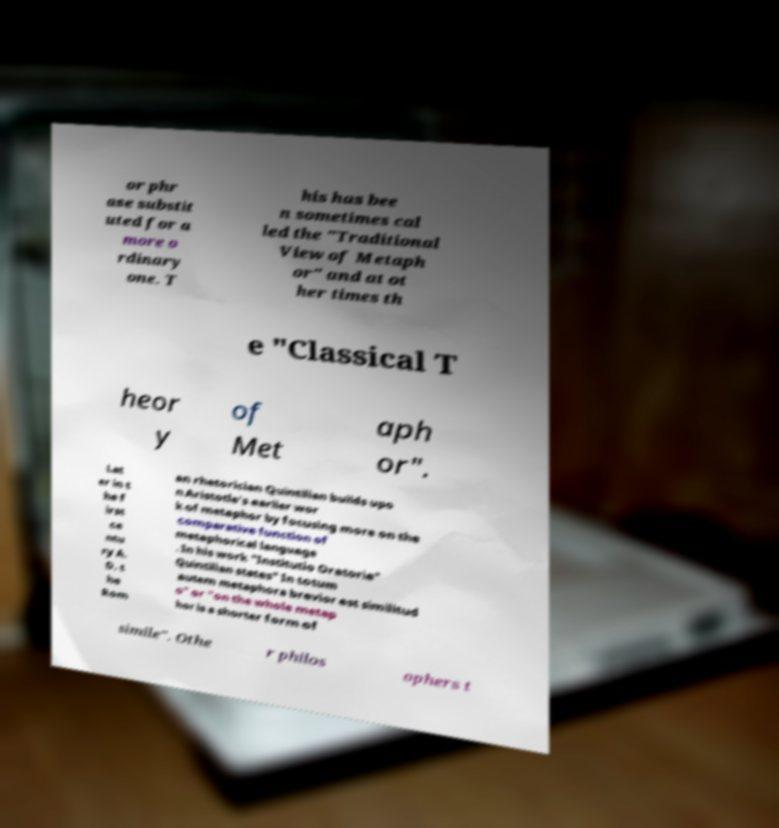Please identify and transcribe the text found in this image. or phr ase substit uted for a more o rdinary one. T his has bee n sometimes cal led the "Traditional View of Metaph or" and at ot her times th e "Classical T heor y of Met aph or". Lat er in t he f irst ce ntu ry A. D. t he Rom an rhetorician Quintilian builds upo n Aristotle's earlier wor k of metaphor by focusing more on the comparative function of metaphorical language . In his work "Institutio Oratoria" Quintilian states" In totum autem metaphora brevior est similitud o" or "on the whole metap hor is a shorter form of simile". Othe r philos ophers t 